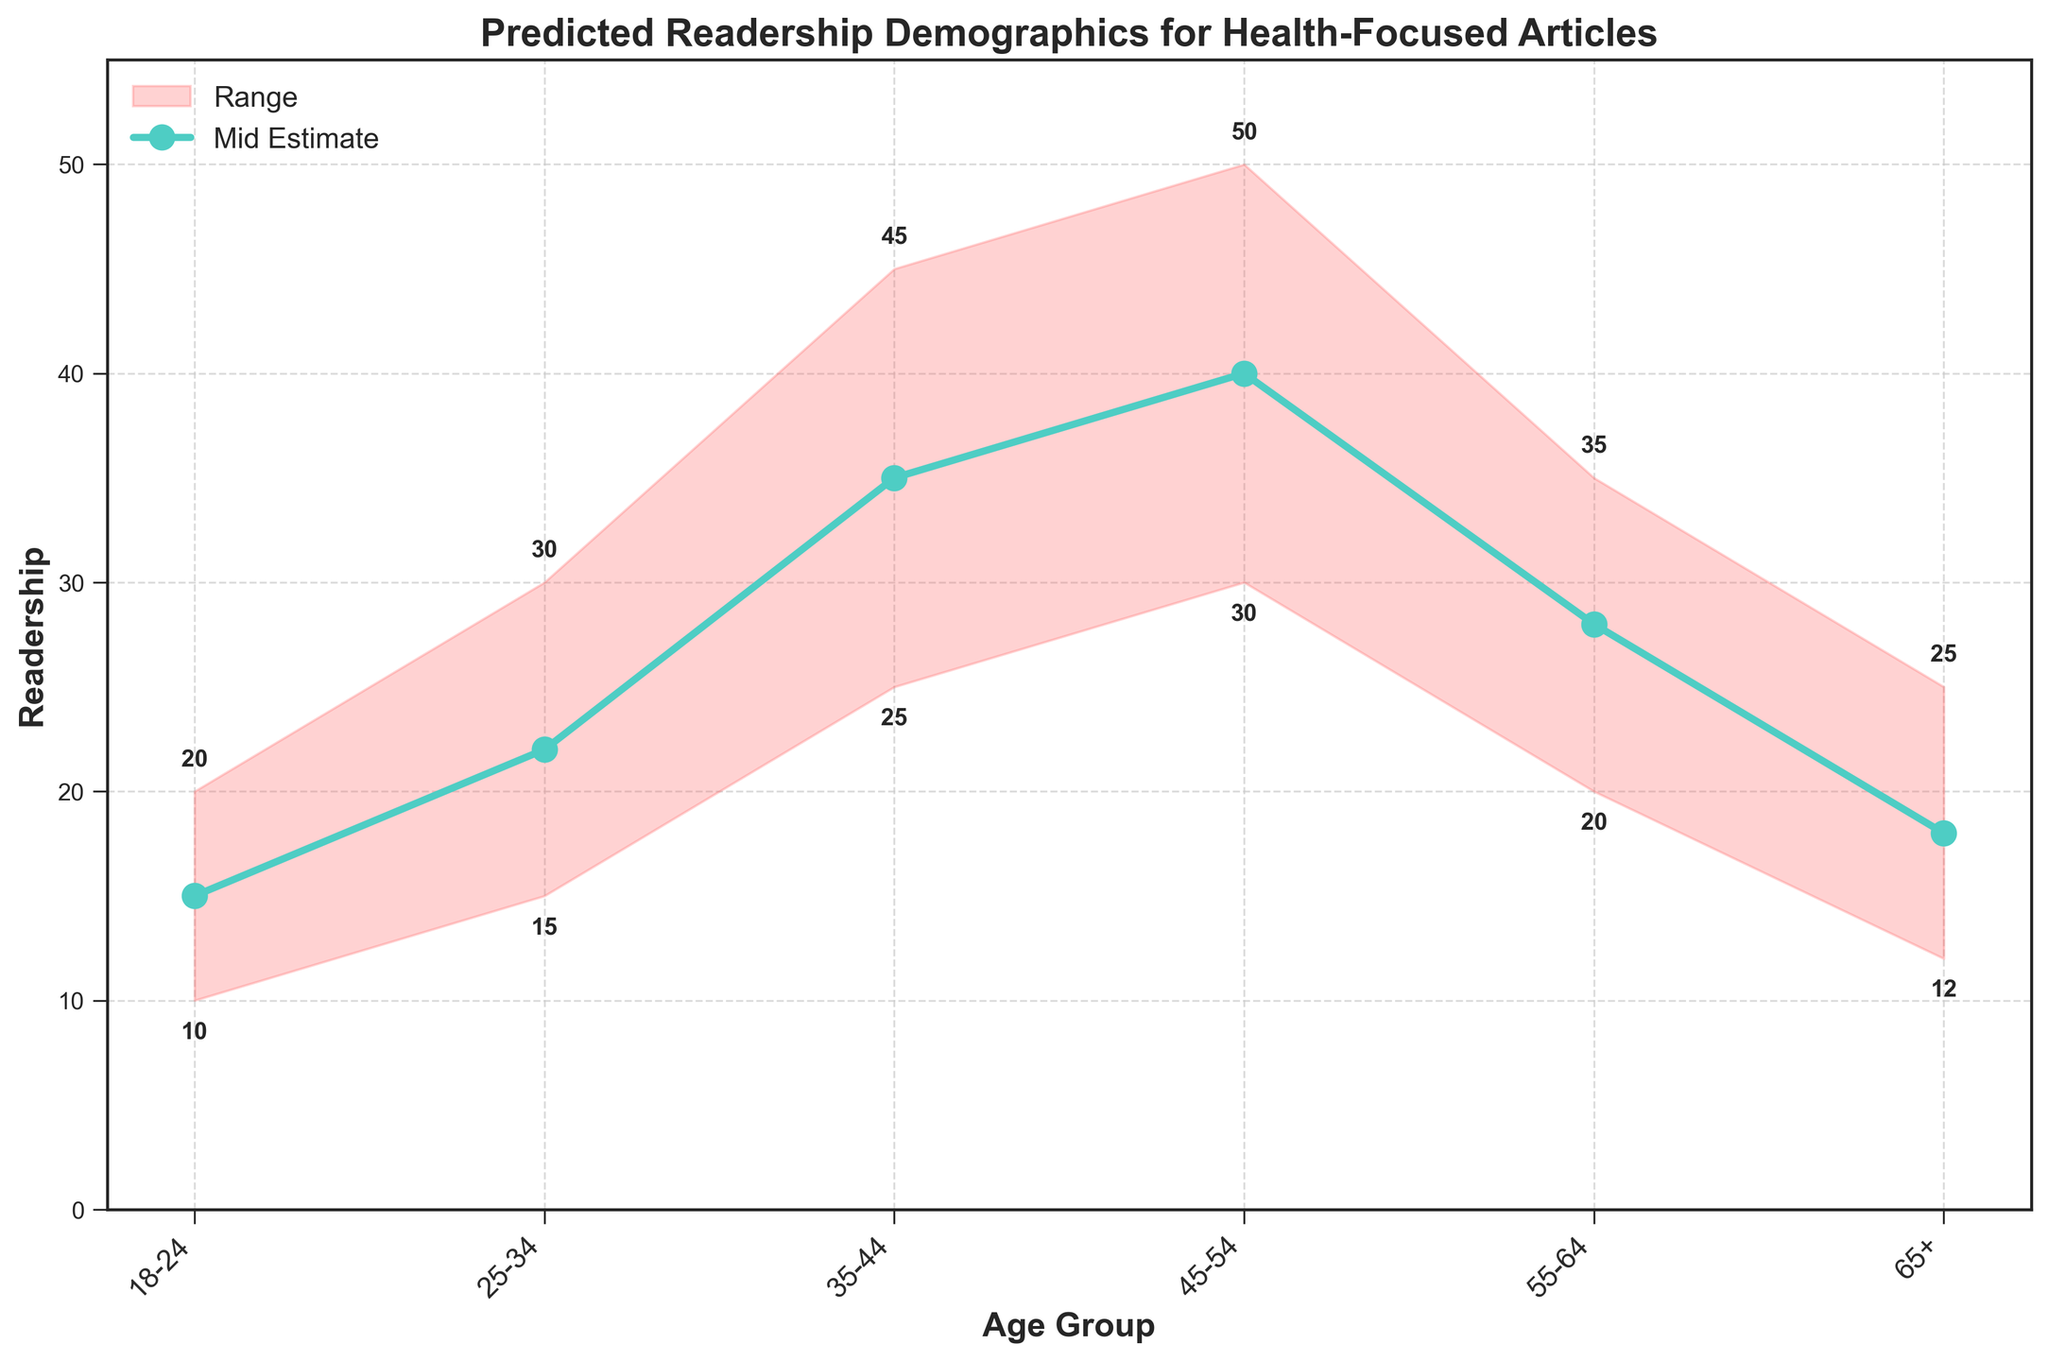What is the title of the figure? The title is usually found at the top of the figure and provides a summary of what the figure represents.
Answer: Predicted Readership Demographics for Health-Focused Articles Which age group has the highest mid estimate? To determine this, look for the highest point along the mid estimate line. The mid estimate line is marked by the colored markers.
Answer: 45-54 What is the low estimate for the 55-64 age group? The low estimate values are along the bottom edge of the shaded area. Find the value aligned with the 55-64 age group.
Answer: 20 What is the range of readership predictions for the 35-44 age group? The range can be calculated by subtracting the low estimate from the high estimate for that age group.
Answer: 20 (45 - 25) Which age group has the smallest predicted readership range? Compare the difference between high and low estimates for each age group and identify the smallest.
Answer: 65+ What is the total predicted readership across all age groups for the mid estimate? Sum up all the mid estimate values for different age groups: 15 + 22 + 35 + 40 + 28 + 18.
Answer: 158 Which age groups have a high estimate greater than 30? Look across the high estimate values and identify which ones are greater than 30.
Answer: 25-34, 35-44, 45-54, 55-64 How does the readership trend change from the 18-24 to the 45-54 age groups according to the mid estimates? Observe the mid estimate points from 18-24 to 45-54 and describe the trend, noting whether it increases, decreases, or stays constant.
Answer: It increases What is the average high estimate for the age groups 35-44 and 45-54? Calculate the average by adding the high estimates of these age groups and then dividing by 2: (45 + 50) / 2.
Answer: 47.5 What color represents the range of estimates in the figure? Identify the color that fills the area between the low and high estimates.
Answer: Light red 